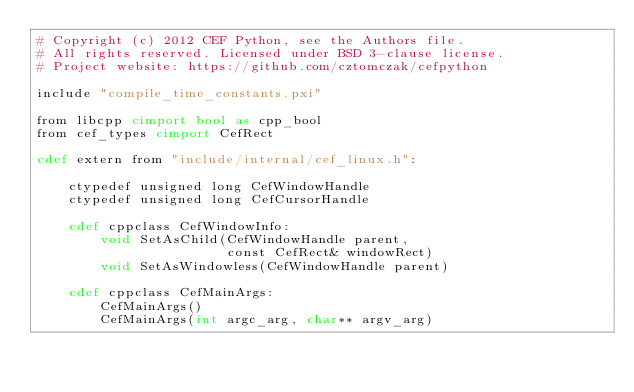<code> <loc_0><loc_0><loc_500><loc_500><_Cython_># Copyright (c) 2012 CEF Python, see the Authors file.
# All rights reserved. Licensed under BSD 3-clause license.
# Project website: https://github.com/cztomczak/cefpython

include "compile_time_constants.pxi"

from libcpp cimport bool as cpp_bool
from cef_types cimport CefRect

cdef extern from "include/internal/cef_linux.h":

    ctypedef unsigned long CefWindowHandle
    ctypedef unsigned long CefCursorHandle

    cdef cppclass CefWindowInfo:
        void SetAsChild(CefWindowHandle parent,
                        const CefRect& windowRect)
        void SetAsWindowless(CefWindowHandle parent)

    cdef cppclass CefMainArgs:
        CefMainArgs()
        CefMainArgs(int argc_arg, char** argv_arg)
</code> 